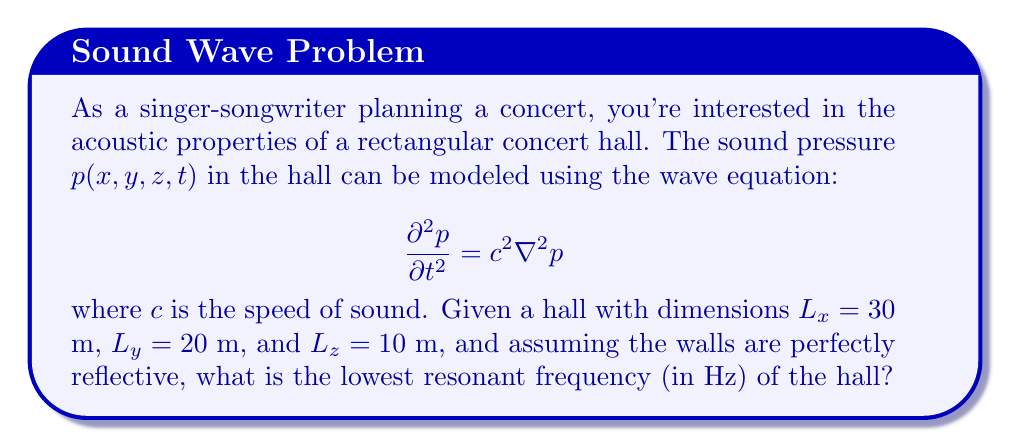Provide a solution to this math problem. To solve this problem, we'll follow these steps:

1) For a rectangular room with perfectly reflective walls, the solution to the wave equation takes the form:

   $$p(x,y,z,t) = \cos(\omega t) \cos(\frac{n_x \pi x}{L_x}) \cos(\frac{n_y \pi y}{L_y}) \cos(\frac{n_z \pi z}{L_z})$$

   where $n_x$, $n_y$, and $n_z$ are non-negative integers.

2) Substituting this into the wave equation, we get the relationship:

   $$\omega^2 = c^2 \pi^2 \left(\frac{n_x^2}{L_x^2} + \frac{n_y^2}{L_y^2} + \frac{n_z^2}{L_z^2}\right)$$

3) The lowest resonant frequency occurs when $n_x = 1$, $n_y = 0$, and $n_z = 0$. Substituting these values:

   $$\omega^2 = c^2 \pi^2 \left(\frac{1^2}{30^2} + \frac{0^2}{20^2} + \frac{0^2}{10^2}\right) = \frac{c^2 \pi^2}{900}$$

4) The frequency $f$ is related to $\omega$ by $\omega = 2\pi f$. Therefore:

   $$f = \frac{c}{2L_x} = \frac{343}{2(30)} \approx 5.72 \text{ Hz}$$

   where we've used $c = 343$ m/s (the speed of sound in air at room temperature).
Answer: 5.72 Hz 